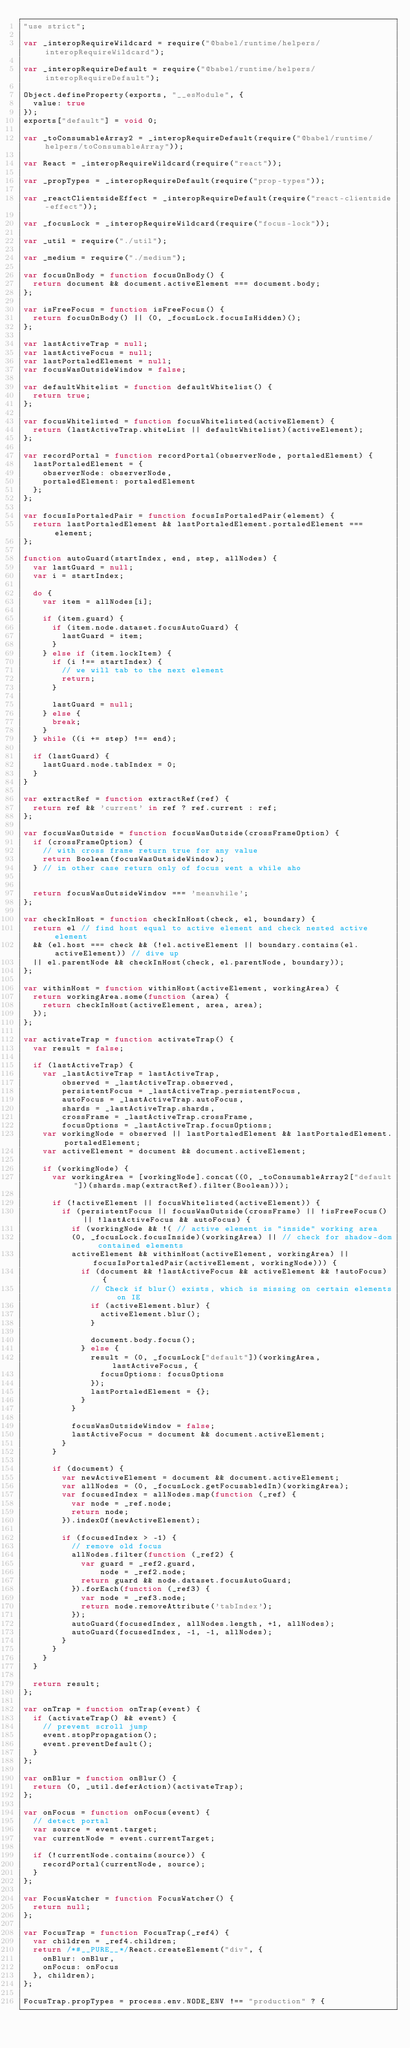<code> <loc_0><loc_0><loc_500><loc_500><_JavaScript_>"use strict";

var _interopRequireWildcard = require("@babel/runtime/helpers/interopRequireWildcard");

var _interopRequireDefault = require("@babel/runtime/helpers/interopRequireDefault");

Object.defineProperty(exports, "__esModule", {
  value: true
});
exports["default"] = void 0;

var _toConsumableArray2 = _interopRequireDefault(require("@babel/runtime/helpers/toConsumableArray"));

var React = _interopRequireWildcard(require("react"));

var _propTypes = _interopRequireDefault(require("prop-types"));

var _reactClientsideEffect = _interopRequireDefault(require("react-clientside-effect"));

var _focusLock = _interopRequireWildcard(require("focus-lock"));

var _util = require("./util");

var _medium = require("./medium");

var focusOnBody = function focusOnBody() {
  return document && document.activeElement === document.body;
};

var isFreeFocus = function isFreeFocus() {
  return focusOnBody() || (0, _focusLock.focusIsHidden)();
};

var lastActiveTrap = null;
var lastActiveFocus = null;
var lastPortaledElement = null;
var focusWasOutsideWindow = false;

var defaultWhitelist = function defaultWhitelist() {
  return true;
};

var focusWhitelisted = function focusWhitelisted(activeElement) {
  return (lastActiveTrap.whiteList || defaultWhitelist)(activeElement);
};

var recordPortal = function recordPortal(observerNode, portaledElement) {
  lastPortaledElement = {
    observerNode: observerNode,
    portaledElement: portaledElement
  };
};

var focusIsPortaledPair = function focusIsPortaledPair(element) {
  return lastPortaledElement && lastPortaledElement.portaledElement === element;
};

function autoGuard(startIndex, end, step, allNodes) {
  var lastGuard = null;
  var i = startIndex;

  do {
    var item = allNodes[i];

    if (item.guard) {
      if (item.node.dataset.focusAutoGuard) {
        lastGuard = item;
      }
    } else if (item.lockItem) {
      if (i !== startIndex) {
        // we will tab to the next element
        return;
      }

      lastGuard = null;
    } else {
      break;
    }
  } while ((i += step) !== end);

  if (lastGuard) {
    lastGuard.node.tabIndex = 0;
  }
}

var extractRef = function extractRef(ref) {
  return ref && 'current' in ref ? ref.current : ref;
};

var focusWasOutside = function focusWasOutside(crossFrameOption) {
  if (crossFrameOption) {
    // with cross frame return true for any value
    return Boolean(focusWasOutsideWindow);
  } // in other case return only of focus went a while aho


  return focusWasOutsideWindow === 'meanwhile';
};

var checkInHost = function checkInHost(check, el, boundary) {
  return el // find host equal to active element and check nested active element
  && (el.host === check && (!el.activeElement || boundary.contains(el.activeElement)) // dive up
  || el.parentNode && checkInHost(check, el.parentNode, boundary));
};

var withinHost = function withinHost(activeElement, workingArea) {
  return workingArea.some(function (area) {
    return checkInHost(activeElement, area, area);
  });
};

var activateTrap = function activateTrap() {
  var result = false;

  if (lastActiveTrap) {
    var _lastActiveTrap = lastActiveTrap,
        observed = _lastActiveTrap.observed,
        persistentFocus = _lastActiveTrap.persistentFocus,
        autoFocus = _lastActiveTrap.autoFocus,
        shards = _lastActiveTrap.shards,
        crossFrame = _lastActiveTrap.crossFrame,
        focusOptions = _lastActiveTrap.focusOptions;
    var workingNode = observed || lastPortaledElement && lastPortaledElement.portaledElement;
    var activeElement = document && document.activeElement;

    if (workingNode) {
      var workingArea = [workingNode].concat((0, _toConsumableArray2["default"])(shards.map(extractRef).filter(Boolean)));

      if (!activeElement || focusWhitelisted(activeElement)) {
        if (persistentFocus || focusWasOutside(crossFrame) || !isFreeFocus() || !lastActiveFocus && autoFocus) {
          if (workingNode && !( // active element is "inside" working area
          (0, _focusLock.focusInside)(workingArea) || // check for shadow-dom contained elements
          activeElement && withinHost(activeElement, workingArea) || focusIsPortaledPair(activeElement, workingNode))) {
            if (document && !lastActiveFocus && activeElement && !autoFocus) {
              // Check if blur() exists, which is missing on certain elements on IE
              if (activeElement.blur) {
                activeElement.blur();
              }

              document.body.focus();
            } else {
              result = (0, _focusLock["default"])(workingArea, lastActiveFocus, {
                focusOptions: focusOptions
              });
              lastPortaledElement = {};
            }
          }

          focusWasOutsideWindow = false;
          lastActiveFocus = document && document.activeElement;
        }
      }

      if (document) {
        var newActiveElement = document && document.activeElement;
        var allNodes = (0, _focusLock.getFocusabledIn)(workingArea);
        var focusedIndex = allNodes.map(function (_ref) {
          var node = _ref.node;
          return node;
        }).indexOf(newActiveElement);

        if (focusedIndex > -1) {
          // remove old focus
          allNodes.filter(function (_ref2) {
            var guard = _ref2.guard,
                node = _ref2.node;
            return guard && node.dataset.focusAutoGuard;
          }).forEach(function (_ref3) {
            var node = _ref3.node;
            return node.removeAttribute('tabIndex');
          });
          autoGuard(focusedIndex, allNodes.length, +1, allNodes);
          autoGuard(focusedIndex, -1, -1, allNodes);
        }
      }
    }
  }

  return result;
};

var onTrap = function onTrap(event) {
  if (activateTrap() && event) {
    // prevent scroll jump
    event.stopPropagation();
    event.preventDefault();
  }
};

var onBlur = function onBlur() {
  return (0, _util.deferAction)(activateTrap);
};

var onFocus = function onFocus(event) {
  // detect portal
  var source = event.target;
  var currentNode = event.currentTarget;

  if (!currentNode.contains(source)) {
    recordPortal(currentNode, source);
  }
};

var FocusWatcher = function FocusWatcher() {
  return null;
};

var FocusTrap = function FocusTrap(_ref4) {
  var children = _ref4.children;
  return /*#__PURE__*/React.createElement("div", {
    onBlur: onBlur,
    onFocus: onFocus
  }, children);
};

FocusTrap.propTypes = process.env.NODE_ENV !== "production" ? {</code> 